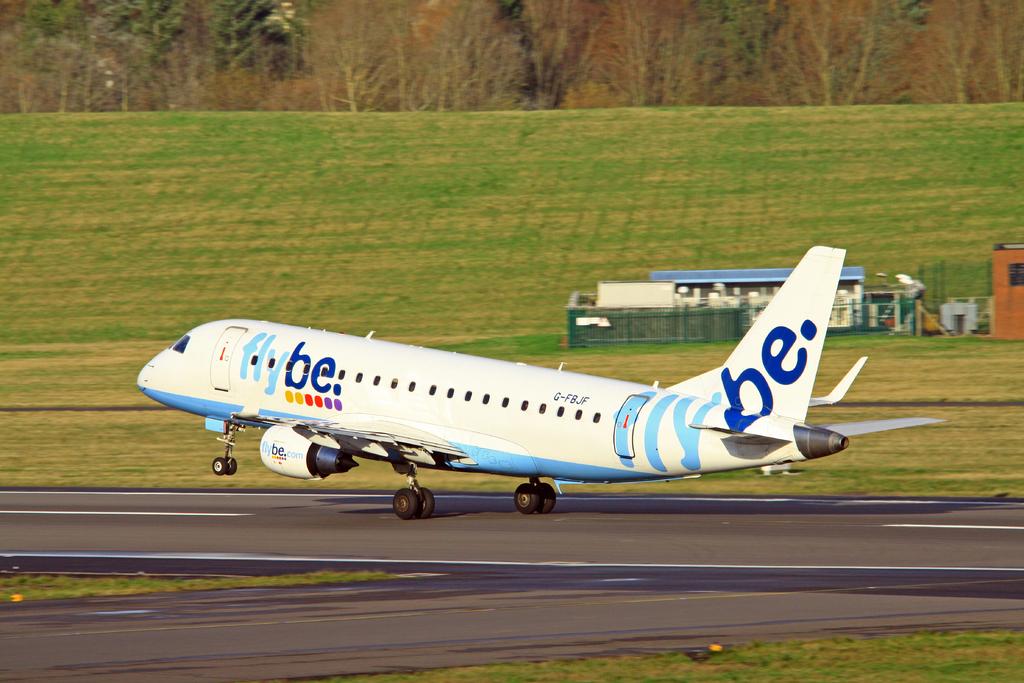What is the name of the airline?
Provide a short and direct response. Flybe. 